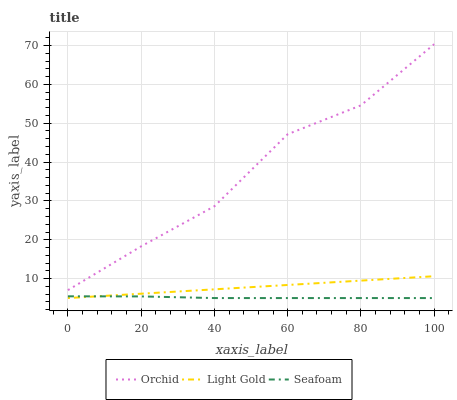Does Seafoam have the minimum area under the curve?
Answer yes or no. Yes. Does Orchid have the maximum area under the curve?
Answer yes or no. Yes. Does Orchid have the minimum area under the curve?
Answer yes or no. No. Does Seafoam have the maximum area under the curve?
Answer yes or no. No. Is Light Gold the smoothest?
Answer yes or no. Yes. Is Orchid the roughest?
Answer yes or no. Yes. Is Seafoam the smoothest?
Answer yes or no. No. Is Seafoam the roughest?
Answer yes or no. No. Does Orchid have the lowest value?
Answer yes or no. No. Does Seafoam have the highest value?
Answer yes or no. No. Is Seafoam less than Orchid?
Answer yes or no. Yes. Is Orchid greater than Light Gold?
Answer yes or no. Yes. Does Seafoam intersect Orchid?
Answer yes or no. No. 